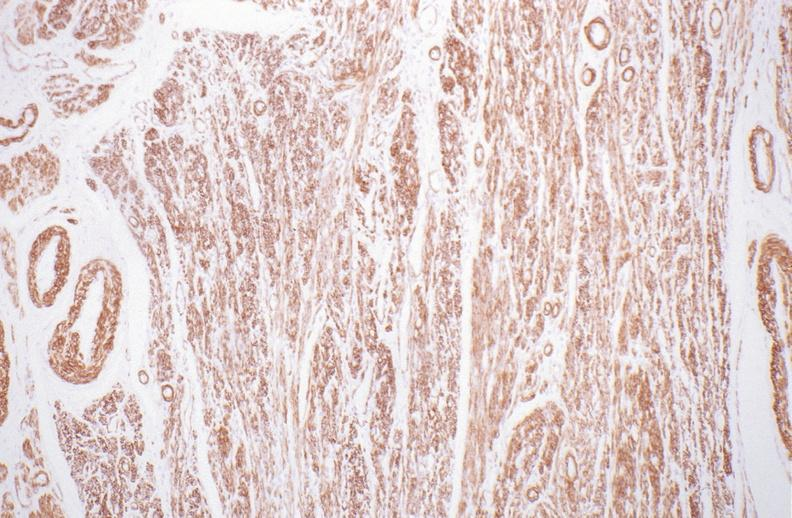does this image show normal uterus?
Answer the question using a single word or phrase. Yes 